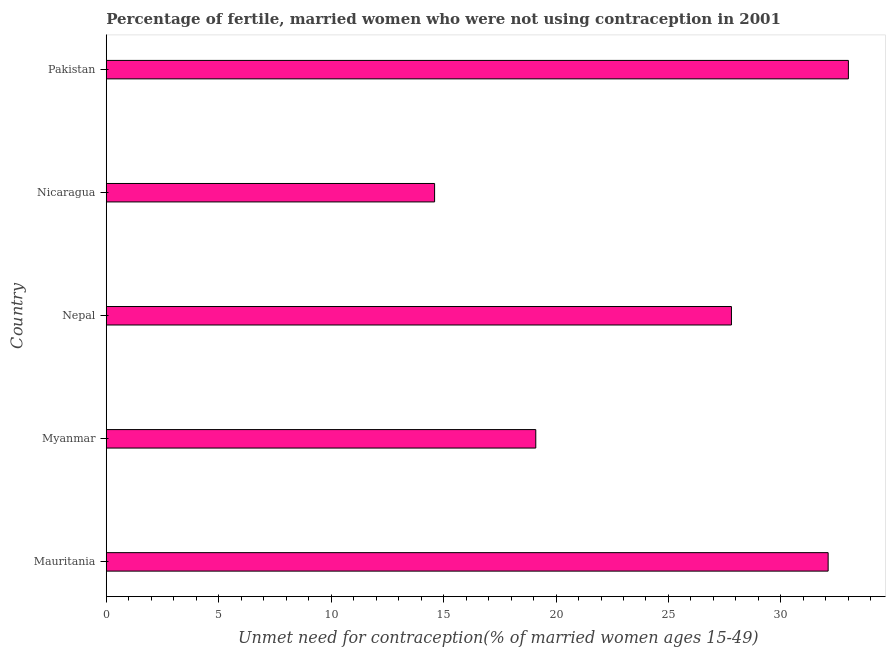Does the graph contain any zero values?
Your answer should be very brief. No. What is the title of the graph?
Your response must be concise. Percentage of fertile, married women who were not using contraception in 2001. What is the label or title of the X-axis?
Your answer should be compact.  Unmet need for contraception(% of married women ages 15-49). Across all countries, what is the minimum number of married women who are not using contraception?
Ensure brevity in your answer.  14.6. In which country was the number of married women who are not using contraception minimum?
Your answer should be very brief. Nicaragua. What is the sum of the number of married women who are not using contraception?
Give a very brief answer. 126.6. What is the average number of married women who are not using contraception per country?
Your response must be concise. 25.32. What is the median number of married women who are not using contraception?
Ensure brevity in your answer.  27.8. What is the ratio of the number of married women who are not using contraception in Myanmar to that in Pakistan?
Make the answer very short. 0.58. Is the number of married women who are not using contraception in Mauritania less than that in Nicaragua?
Your response must be concise. No. What is the difference between the highest and the second highest number of married women who are not using contraception?
Keep it short and to the point. 0.9. Is the sum of the number of married women who are not using contraception in Mauritania and Nepal greater than the maximum number of married women who are not using contraception across all countries?
Offer a terse response. Yes. In how many countries, is the number of married women who are not using contraception greater than the average number of married women who are not using contraception taken over all countries?
Your answer should be compact. 3. Are all the bars in the graph horizontal?
Your answer should be compact. Yes. How many countries are there in the graph?
Your response must be concise. 5. Are the values on the major ticks of X-axis written in scientific E-notation?
Keep it short and to the point. No. What is the  Unmet need for contraception(% of married women ages 15-49) of Mauritania?
Give a very brief answer. 32.1. What is the  Unmet need for contraception(% of married women ages 15-49) of Myanmar?
Give a very brief answer. 19.1. What is the  Unmet need for contraception(% of married women ages 15-49) in Nepal?
Your response must be concise. 27.8. What is the  Unmet need for contraception(% of married women ages 15-49) of Nicaragua?
Ensure brevity in your answer.  14.6. What is the difference between the  Unmet need for contraception(% of married women ages 15-49) in Mauritania and Nepal?
Keep it short and to the point. 4.3. What is the difference between the  Unmet need for contraception(% of married women ages 15-49) in Mauritania and Nicaragua?
Make the answer very short. 17.5. What is the difference between the  Unmet need for contraception(% of married women ages 15-49) in Mauritania and Pakistan?
Your answer should be very brief. -0.9. What is the difference between the  Unmet need for contraception(% of married women ages 15-49) in Myanmar and Nepal?
Provide a short and direct response. -8.7. What is the difference between the  Unmet need for contraception(% of married women ages 15-49) in Myanmar and Pakistan?
Offer a very short reply. -13.9. What is the difference between the  Unmet need for contraception(% of married women ages 15-49) in Nepal and Pakistan?
Your answer should be very brief. -5.2. What is the difference between the  Unmet need for contraception(% of married women ages 15-49) in Nicaragua and Pakistan?
Your answer should be compact. -18.4. What is the ratio of the  Unmet need for contraception(% of married women ages 15-49) in Mauritania to that in Myanmar?
Keep it short and to the point. 1.68. What is the ratio of the  Unmet need for contraception(% of married women ages 15-49) in Mauritania to that in Nepal?
Your answer should be very brief. 1.16. What is the ratio of the  Unmet need for contraception(% of married women ages 15-49) in Mauritania to that in Nicaragua?
Your answer should be very brief. 2.2. What is the ratio of the  Unmet need for contraception(% of married women ages 15-49) in Myanmar to that in Nepal?
Your response must be concise. 0.69. What is the ratio of the  Unmet need for contraception(% of married women ages 15-49) in Myanmar to that in Nicaragua?
Offer a terse response. 1.31. What is the ratio of the  Unmet need for contraception(% of married women ages 15-49) in Myanmar to that in Pakistan?
Make the answer very short. 0.58. What is the ratio of the  Unmet need for contraception(% of married women ages 15-49) in Nepal to that in Nicaragua?
Offer a very short reply. 1.9. What is the ratio of the  Unmet need for contraception(% of married women ages 15-49) in Nepal to that in Pakistan?
Your response must be concise. 0.84. What is the ratio of the  Unmet need for contraception(% of married women ages 15-49) in Nicaragua to that in Pakistan?
Make the answer very short. 0.44. 